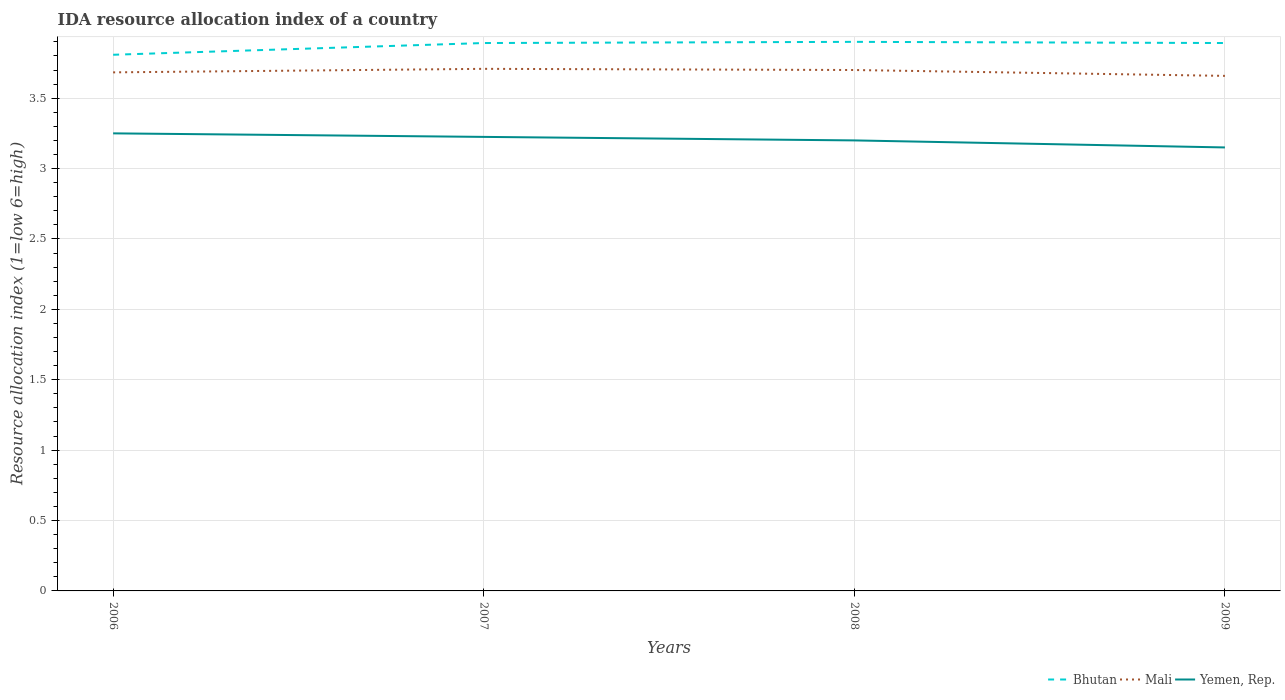How many different coloured lines are there?
Provide a succinct answer. 3. Is the number of lines equal to the number of legend labels?
Provide a succinct answer. Yes. Across all years, what is the maximum IDA resource allocation index in Yemen, Rep.?
Keep it short and to the point. 3.15. In which year was the IDA resource allocation index in Yemen, Rep. maximum?
Provide a short and direct response. 2009. What is the total IDA resource allocation index in Mali in the graph?
Make the answer very short. 0.05. What is the difference between the highest and the second highest IDA resource allocation index in Yemen, Rep.?
Make the answer very short. 0.1. What is the difference between the highest and the lowest IDA resource allocation index in Mali?
Offer a terse response. 2. Is the IDA resource allocation index in Yemen, Rep. strictly greater than the IDA resource allocation index in Mali over the years?
Offer a very short reply. Yes. How many lines are there?
Your answer should be very brief. 3. How many years are there in the graph?
Offer a terse response. 4. What is the difference between two consecutive major ticks on the Y-axis?
Your response must be concise. 0.5. Are the values on the major ticks of Y-axis written in scientific E-notation?
Your answer should be compact. No. Does the graph contain grids?
Ensure brevity in your answer.  Yes. Where does the legend appear in the graph?
Your answer should be compact. Bottom right. How many legend labels are there?
Ensure brevity in your answer.  3. How are the legend labels stacked?
Provide a short and direct response. Horizontal. What is the title of the graph?
Make the answer very short. IDA resource allocation index of a country. Does "Zimbabwe" appear as one of the legend labels in the graph?
Your answer should be very brief. No. What is the label or title of the Y-axis?
Offer a very short reply. Resource allocation index (1=low 6=high). What is the Resource allocation index (1=low 6=high) in Bhutan in 2006?
Your response must be concise. 3.81. What is the Resource allocation index (1=low 6=high) of Mali in 2006?
Keep it short and to the point. 3.68. What is the Resource allocation index (1=low 6=high) in Bhutan in 2007?
Ensure brevity in your answer.  3.89. What is the Resource allocation index (1=low 6=high) of Mali in 2007?
Your answer should be very brief. 3.71. What is the Resource allocation index (1=low 6=high) in Yemen, Rep. in 2007?
Your response must be concise. 3.23. What is the Resource allocation index (1=low 6=high) in Bhutan in 2008?
Provide a succinct answer. 3.9. What is the Resource allocation index (1=low 6=high) of Mali in 2008?
Provide a short and direct response. 3.7. What is the Resource allocation index (1=low 6=high) of Yemen, Rep. in 2008?
Your answer should be compact. 3.2. What is the Resource allocation index (1=low 6=high) in Bhutan in 2009?
Give a very brief answer. 3.89. What is the Resource allocation index (1=low 6=high) in Mali in 2009?
Provide a succinct answer. 3.66. What is the Resource allocation index (1=low 6=high) of Yemen, Rep. in 2009?
Your answer should be very brief. 3.15. Across all years, what is the maximum Resource allocation index (1=low 6=high) of Bhutan?
Ensure brevity in your answer.  3.9. Across all years, what is the maximum Resource allocation index (1=low 6=high) in Mali?
Your answer should be compact. 3.71. Across all years, what is the maximum Resource allocation index (1=low 6=high) of Yemen, Rep.?
Make the answer very short. 3.25. Across all years, what is the minimum Resource allocation index (1=low 6=high) in Bhutan?
Offer a very short reply. 3.81. Across all years, what is the minimum Resource allocation index (1=low 6=high) of Mali?
Your answer should be very brief. 3.66. Across all years, what is the minimum Resource allocation index (1=low 6=high) in Yemen, Rep.?
Offer a terse response. 3.15. What is the total Resource allocation index (1=low 6=high) in Bhutan in the graph?
Make the answer very short. 15.49. What is the total Resource allocation index (1=low 6=high) in Mali in the graph?
Make the answer very short. 14.75. What is the total Resource allocation index (1=low 6=high) of Yemen, Rep. in the graph?
Your response must be concise. 12.82. What is the difference between the Resource allocation index (1=low 6=high) of Bhutan in 2006 and that in 2007?
Provide a short and direct response. -0.08. What is the difference between the Resource allocation index (1=low 6=high) in Mali in 2006 and that in 2007?
Your response must be concise. -0.03. What is the difference between the Resource allocation index (1=low 6=high) of Yemen, Rep. in 2006 and that in 2007?
Your response must be concise. 0.03. What is the difference between the Resource allocation index (1=low 6=high) in Bhutan in 2006 and that in 2008?
Offer a very short reply. -0.09. What is the difference between the Resource allocation index (1=low 6=high) of Mali in 2006 and that in 2008?
Give a very brief answer. -0.02. What is the difference between the Resource allocation index (1=low 6=high) in Yemen, Rep. in 2006 and that in 2008?
Your answer should be compact. 0.05. What is the difference between the Resource allocation index (1=low 6=high) of Bhutan in 2006 and that in 2009?
Give a very brief answer. -0.08. What is the difference between the Resource allocation index (1=low 6=high) of Mali in 2006 and that in 2009?
Keep it short and to the point. 0.03. What is the difference between the Resource allocation index (1=low 6=high) in Bhutan in 2007 and that in 2008?
Provide a short and direct response. -0.01. What is the difference between the Resource allocation index (1=low 6=high) of Mali in 2007 and that in 2008?
Your response must be concise. 0.01. What is the difference between the Resource allocation index (1=low 6=high) in Yemen, Rep. in 2007 and that in 2008?
Provide a succinct answer. 0.03. What is the difference between the Resource allocation index (1=low 6=high) in Bhutan in 2007 and that in 2009?
Keep it short and to the point. 0. What is the difference between the Resource allocation index (1=low 6=high) of Mali in 2007 and that in 2009?
Offer a terse response. 0.05. What is the difference between the Resource allocation index (1=low 6=high) in Yemen, Rep. in 2007 and that in 2009?
Offer a very short reply. 0.07. What is the difference between the Resource allocation index (1=low 6=high) of Bhutan in 2008 and that in 2009?
Provide a short and direct response. 0.01. What is the difference between the Resource allocation index (1=low 6=high) in Mali in 2008 and that in 2009?
Offer a terse response. 0.04. What is the difference between the Resource allocation index (1=low 6=high) in Yemen, Rep. in 2008 and that in 2009?
Offer a very short reply. 0.05. What is the difference between the Resource allocation index (1=low 6=high) of Bhutan in 2006 and the Resource allocation index (1=low 6=high) of Mali in 2007?
Provide a succinct answer. 0.1. What is the difference between the Resource allocation index (1=low 6=high) of Bhutan in 2006 and the Resource allocation index (1=low 6=high) of Yemen, Rep. in 2007?
Provide a succinct answer. 0.58. What is the difference between the Resource allocation index (1=low 6=high) of Mali in 2006 and the Resource allocation index (1=low 6=high) of Yemen, Rep. in 2007?
Offer a very short reply. 0.46. What is the difference between the Resource allocation index (1=low 6=high) in Bhutan in 2006 and the Resource allocation index (1=low 6=high) in Mali in 2008?
Keep it short and to the point. 0.11. What is the difference between the Resource allocation index (1=low 6=high) in Bhutan in 2006 and the Resource allocation index (1=low 6=high) in Yemen, Rep. in 2008?
Offer a terse response. 0.61. What is the difference between the Resource allocation index (1=low 6=high) in Mali in 2006 and the Resource allocation index (1=low 6=high) in Yemen, Rep. in 2008?
Offer a very short reply. 0.48. What is the difference between the Resource allocation index (1=low 6=high) of Bhutan in 2006 and the Resource allocation index (1=low 6=high) of Mali in 2009?
Provide a short and direct response. 0.15. What is the difference between the Resource allocation index (1=low 6=high) of Bhutan in 2006 and the Resource allocation index (1=low 6=high) of Yemen, Rep. in 2009?
Make the answer very short. 0.66. What is the difference between the Resource allocation index (1=low 6=high) in Mali in 2006 and the Resource allocation index (1=low 6=high) in Yemen, Rep. in 2009?
Provide a short and direct response. 0.53. What is the difference between the Resource allocation index (1=low 6=high) in Bhutan in 2007 and the Resource allocation index (1=low 6=high) in Mali in 2008?
Keep it short and to the point. 0.19. What is the difference between the Resource allocation index (1=low 6=high) of Bhutan in 2007 and the Resource allocation index (1=low 6=high) of Yemen, Rep. in 2008?
Keep it short and to the point. 0.69. What is the difference between the Resource allocation index (1=low 6=high) of Mali in 2007 and the Resource allocation index (1=low 6=high) of Yemen, Rep. in 2008?
Your answer should be compact. 0.51. What is the difference between the Resource allocation index (1=low 6=high) of Bhutan in 2007 and the Resource allocation index (1=low 6=high) of Mali in 2009?
Your answer should be compact. 0.23. What is the difference between the Resource allocation index (1=low 6=high) of Bhutan in 2007 and the Resource allocation index (1=low 6=high) of Yemen, Rep. in 2009?
Keep it short and to the point. 0.74. What is the difference between the Resource allocation index (1=low 6=high) of Mali in 2007 and the Resource allocation index (1=low 6=high) of Yemen, Rep. in 2009?
Provide a short and direct response. 0.56. What is the difference between the Resource allocation index (1=low 6=high) of Bhutan in 2008 and the Resource allocation index (1=low 6=high) of Mali in 2009?
Your answer should be compact. 0.24. What is the difference between the Resource allocation index (1=low 6=high) of Bhutan in 2008 and the Resource allocation index (1=low 6=high) of Yemen, Rep. in 2009?
Your response must be concise. 0.75. What is the difference between the Resource allocation index (1=low 6=high) in Mali in 2008 and the Resource allocation index (1=low 6=high) in Yemen, Rep. in 2009?
Your answer should be very brief. 0.55. What is the average Resource allocation index (1=low 6=high) of Bhutan per year?
Provide a succinct answer. 3.87. What is the average Resource allocation index (1=low 6=high) of Mali per year?
Your answer should be compact. 3.69. What is the average Resource allocation index (1=low 6=high) in Yemen, Rep. per year?
Your answer should be compact. 3.21. In the year 2006, what is the difference between the Resource allocation index (1=low 6=high) in Bhutan and Resource allocation index (1=low 6=high) in Yemen, Rep.?
Provide a short and direct response. 0.56. In the year 2006, what is the difference between the Resource allocation index (1=low 6=high) in Mali and Resource allocation index (1=low 6=high) in Yemen, Rep.?
Provide a short and direct response. 0.43. In the year 2007, what is the difference between the Resource allocation index (1=low 6=high) of Bhutan and Resource allocation index (1=low 6=high) of Mali?
Your response must be concise. 0.18. In the year 2007, what is the difference between the Resource allocation index (1=low 6=high) in Bhutan and Resource allocation index (1=low 6=high) in Yemen, Rep.?
Provide a short and direct response. 0.67. In the year 2007, what is the difference between the Resource allocation index (1=low 6=high) of Mali and Resource allocation index (1=low 6=high) of Yemen, Rep.?
Your answer should be very brief. 0.48. In the year 2009, what is the difference between the Resource allocation index (1=low 6=high) in Bhutan and Resource allocation index (1=low 6=high) in Mali?
Ensure brevity in your answer.  0.23. In the year 2009, what is the difference between the Resource allocation index (1=low 6=high) of Bhutan and Resource allocation index (1=low 6=high) of Yemen, Rep.?
Give a very brief answer. 0.74. In the year 2009, what is the difference between the Resource allocation index (1=low 6=high) of Mali and Resource allocation index (1=low 6=high) of Yemen, Rep.?
Your response must be concise. 0.51. What is the ratio of the Resource allocation index (1=low 6=high) of Bhutan in 2006 to that in 2007?
Your answer should be compact. 0.98. What is the ratio of the Resource allocation index (1=low 6=high) in Bhutan in 2006 to that in 2008?
Provide a succinct answer. 0.98. What is the ratio of the Resource allocation index (1=low 6=high) of Mali in 2006 to that in 2008?
Your answer should be very brief. 1. What is the ratio of the Resource allocation index (1=low 6=high) in Yemen, Rep. in 2006 to that in 2008?
Keep it short and to the point. 1.02. What is the ratio of the Resource allocation index (1=low 6=high) of Bhutan in 2006 to that in 2009?
Provide a short and direct response. 0.98. What is the ratio of the Resource allocation index (1=low 6=high) of Mali in 2006 to that in 2009?
Offer a very short reply. 1.01. What is the ratio of the Resource allocation index (1=low 6=high) in Yemen, Rep. in 2006 to that in 2009?
Keep it short and to the point. 1.03. What is the ratio of the Resource allocation index (1=low 6=high) in Bhutan in 2007 to that in 2008?
Keep it short and to the point. 1. What is the ratio of the Resource allocation index (1=low 6=high) of Yemen, Rep. in 2007 to that in 2008?
Keep it short and to the point. 1.01. What is the ratio of the Resource allocation index (1=low 6=high) in Mali in 2007 to that in 2009?
Your response must be concise. 1.01. What is the ratio of the Resource allocation index (1=low 6=high) of Yemen, Rep. in 2007 to that in 2009?
Ensure brevity in your answer.  1.02. What is the ratio of the Resource allocation index (1=low 6=high) in Bhutan in 2008 to that in 2009?
Provide a succinct answer. 1. What is the ratio of the Resource allocation index (1=low 6=high) in Mali in 2008 to that in 2009?
Your answer should be compact. 1.01. What is the ratio of the Resource allocation index (1=low 6=high) of Yemen, Rep. in 2008 to that in 2009?
Your answer should be compact. 1.02. What is the difference between the highest and the second highest Resource allocation index (1=low 6=high) of Bhutan?
Make the answer very short. 0.01. What is the difference between the highest and the second highest Resource allocation index (1=low 6=high) in Mali?
Offer a terse response. 0.01. What is the difference between the highest and the second highest Resource allocation index (1=low 6=high) in Yemen, Rep.?
Offer a terse response. 0.03. What is the difference between the highest and the lowest Resource allocation index (1=low 6=high) of Bhutan?
Your answer should be very brief. 0.09. What is the difference between the highest and the lowest Resource allocation index (1=low 6=high) in Yemen, Rep.?
Offer a very short reply. 0.1. 